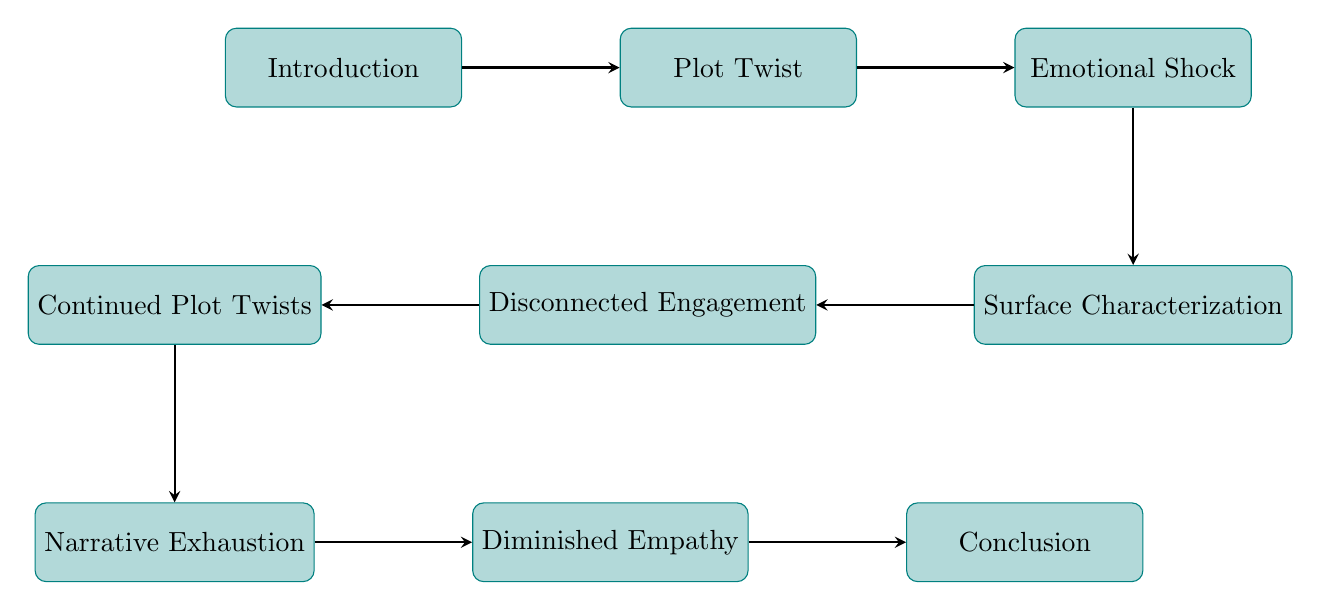What is the first node in the flow chart? The first node is identified in the diagram, and is labeled as "Introduction." This is the starting point of the reader’s emotional journey.
Answer: Introduction How many nodes are there in the flow chart? By counting the individual elements represented in the diagram, there are nine distinct nodes that describe different stages in the emotional journey.
Answer: Nine What comes after "Emotional Shock" in the flow chart? The flow sequence from "Emotional Shock" leads to "Surface Characterization," which is the next phase after the shock experienced by the reader.
Answer: Surface Characterization Which node indicates a lack of emotional connection? The node labeled "Disconnected Engagement" signifies the stage where the reader begins to lose their emotional connection to the characters, following the superficial characterization.
Answer: Disconnected Engagement What is the final outcome described in the flow chart? The last node in the sequence is "Conclusion," which summarizes the story and often leaves the character arcs unresolved, indicating the end of the reader's journey.
Answer: Conclusion What happens between "Surface Characterization" and "Continued Plot Twists"? After the "Surface Characterization" stage, the reader's journey progresses to the "Disconnected Engagement" phase, signaling a decline in emotional connection before more unexpected events unfold.
Answer: Disconnected Engagement What is the effect of "Narrative Exhaustion" on character empathy? The node "Diminished Empathy" follows "Narrative Exhaustion," indicating that the exhaustion experienced by the reader is directly related to a decrease in their empathy for the characters, due to insufficient character exploration.
Answer: Diminished Empathy How are "Plot Twists" and "Emotional Shock" connected? "Plot Twist" directly leads to "Emotional Shock," showing that the introduction of an unexpected event prompts an immediate emotional reaction from the reader.
Answer: Emotional Shock 